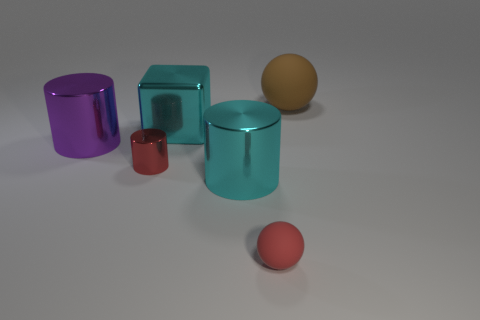What number of cyan things are big metal cylinders or big rubber spheres?
Your answer should be very brief. 1. What size is the matte thing that is the same color as the small metal cylinder?
Your response must be concise. Small. Is the number of big blocks greater than the number of large red objects?
Give a very brief answer. Yes. Is the big ball the same color as the small metal cylinder?
Your answer should be very brief. No. How many things are big balls or tiny rubber objects on the right side of the tiny red metal object?
Your answer should be very brief. 2. What number of other things are the same shape as the tiny red matte thing?
Your answer should be compact. 1. Is the number of large metallic cubes left of the tiny red metallic cylinder less than the number of shiny blocks to the left of the red matte object?
Your answer should be very brief. Yes. Are there any other things that are made of the same material as the large purple cylinder?
Your answer should be very brief. Yes. There is a big purple thing that is made of the same material as the small cylinder; what is its shape?
Provide a short and direct response. Cylinder. Is there anything else that is the same color as the metallic cube?
Give a very brief answer. Yes. 